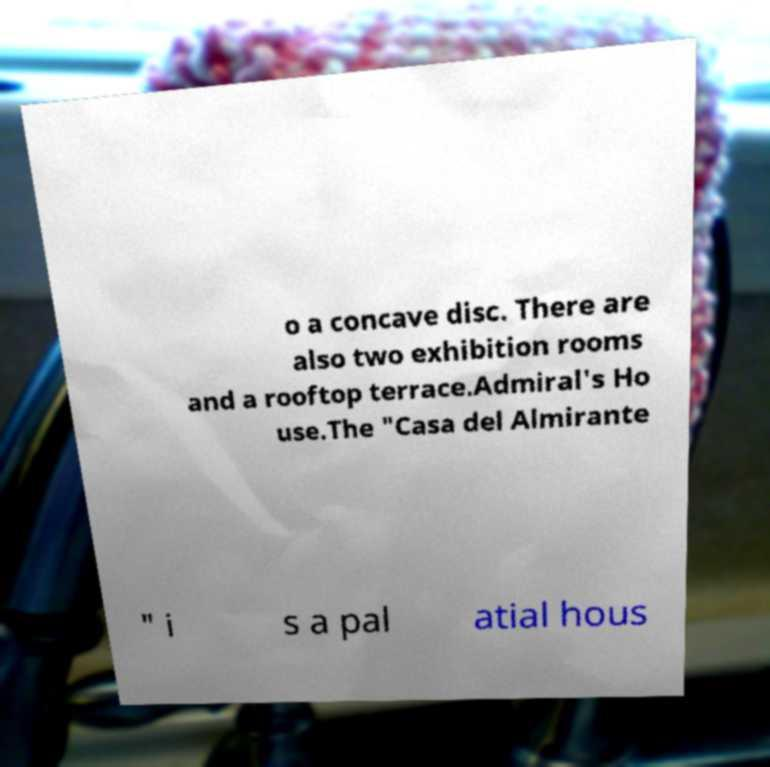There's text embedded in this image that I need extracted. Can you transcribe it verbatim? o a concave disc. There are also two exhibition rooms and a rooftop terrace.Admiral's Ho use.The "Casa del Almirante " i s a pal atial hous 